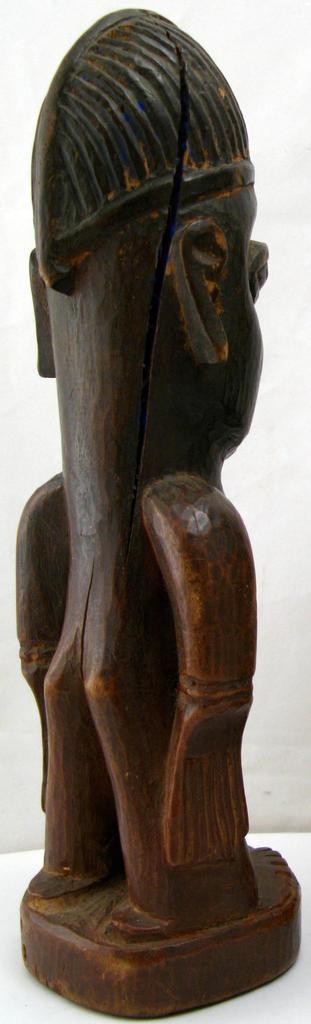How would you summarize this image in a sentence or two? In this picture we can see a wooden sculpture. 